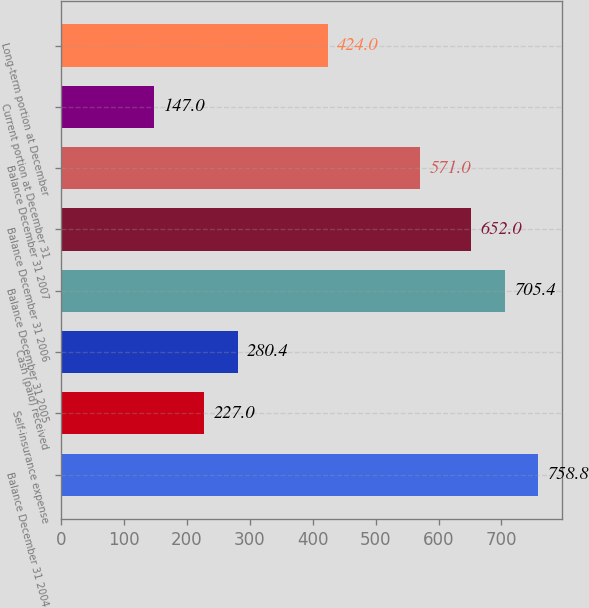<chart> <loc_0><loc_0><loc_500><loc_500><bar_chart><fcel>Balance December 31 2004<fcel>Self-insurance expense<fcel>Cash (paid) received<fcel>Balance December 31 2005<fcel>Balance December 31 2006<fcel>Balance December 31 2007<fcel>Current portion at December 31<fcel>Long-term portion at December<nl><fcel>758.8<fcel>227<fcel>280.4<fcel>705.4<fcel>652<fcel>571<fcel>147<fcel>424<nl></chart> 